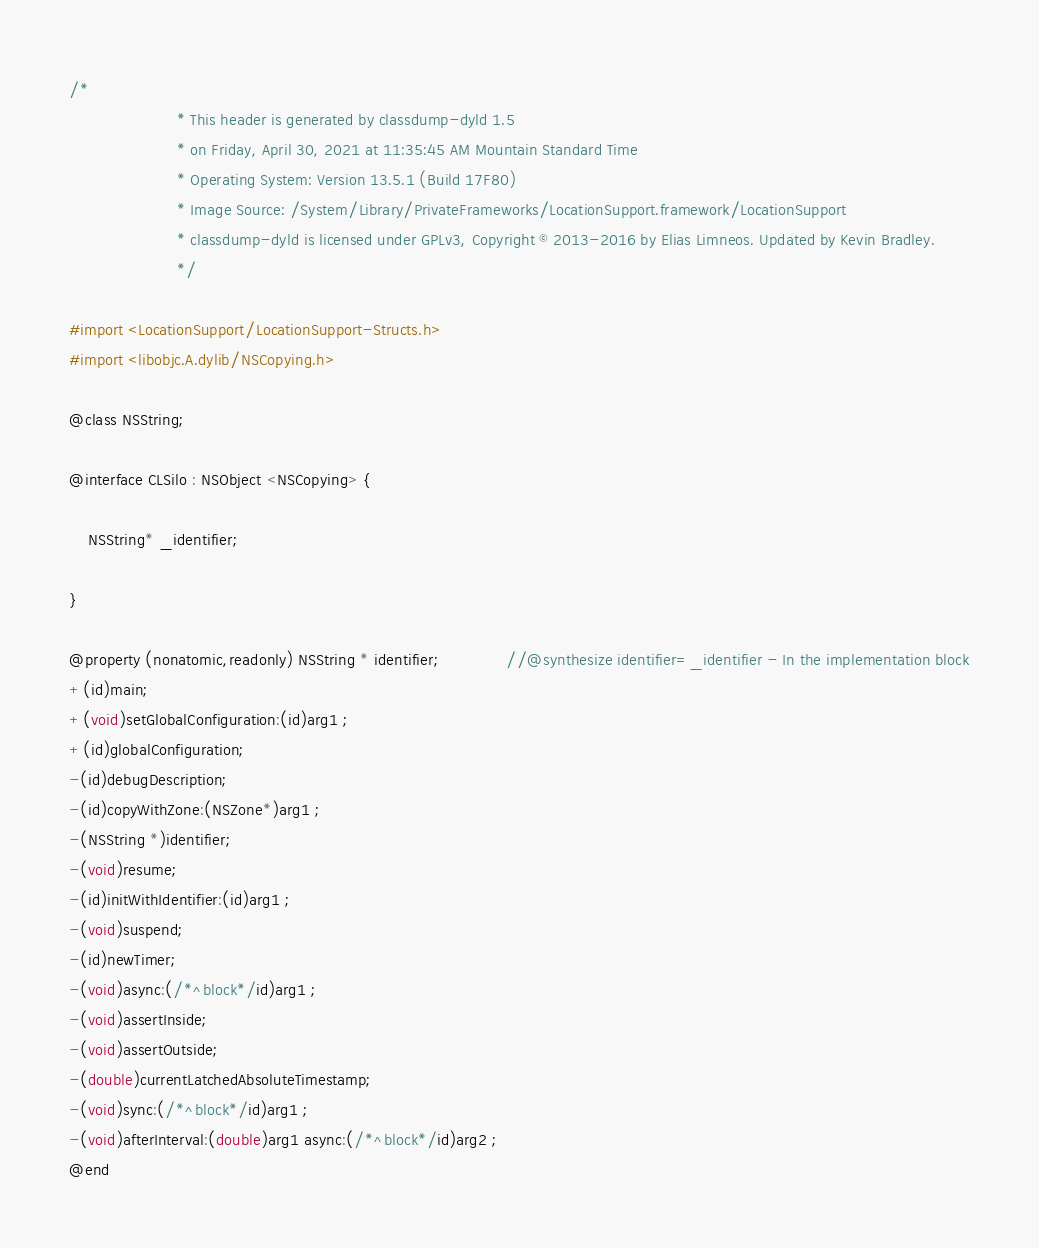Convert code to text. <code><loc_0><loc_0><loc_500><loc_500><_C_>/*
                       * This header is generated by classdump-dyld 1.5
                       * on Friday, April 30, 2021 at 11:35:45 AM Mountain Standard Time
                       * Operating System: Version 13.5.1 (Build 17F80)
                       * Image Source: /System/Library/PrivateFrameworks/LocationSupport.framework/LocationSupport
                       * classdump-dyld is licensed under GPLv3, Copyright © 2013-2016 by Elias Limneos. Updated by Kevin Bradley.
                       */

#import <LocationSupport/LocationSupport-Structs.h>
#import <libobjc.A.dylib/NSCopying.h>

@class NSString;

@interface CLSilo : NSObject <NSCopying> {

	NSString* _identifier;

}

@property (nonatomic,readonly) NSString * identifier;              //@synthesize identifier=_identifier - In the implementation block
+(id)main;
+(void)setGlobalConfiguration:(id)arg1 ;
+(id)globalConfiguration;
-(id)debugDescription;
-(id)copyWithZone:(NSZone*)arg1 ;
-(NSString *)identifier;
-(void)resume;
-(id)initWithIdentifier:(id)arg1 ;
-(void)suspend;
-(id)newTimer;
-(void)async:(/*^block*/id)arg1 ;
-(void)assertInside;
-(void)assertOutside;
-(double)currentLatchedAbsoluteTimestamp;
-(void)sync:(/*^block*/id)arg1 ;
-(void)afterInterval:(double)arg1 async:(/*^block*/id)arg2 ;
@end

</code> 